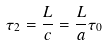<formula> <loc_0><loc_0><loc_500><loc_500>\tau _ { 2 } = \frac { L } { c } = \frac { L } { a } \tau _ { 0 }</formula> 